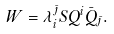Convert formula to latex. <formula><loc_0><loc_0><loc_500><loc_500>W = \lambda _ { i } ^ { \bar { \jmath } } S Q ^ { i } \bar { Q } _ { \bar { \jmath } } .</formula> 